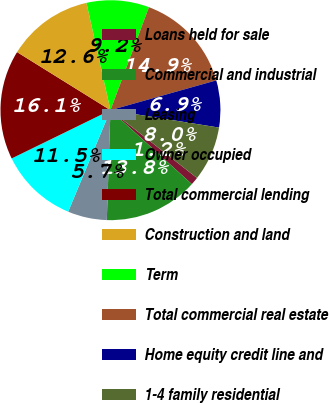Convert chart to OTSL. <chart><loc_0><loc_0><loc_500><loc_500><pie_chart><fcel>Loans held for sale<fcel>Commercial and industrial<fcel>Leasing<fcel>Owner occupied<fcel>Total commercial lending<fcel>Construction and land<fcel>Term<fcel>Total commercial real estate<fcel>Home equity credit line and<fcel>1-4 family residential<nl><fcel>1.16%<fcel>13.79%<fcel>5.75%<fcel>11.49%<fcel>16.09%<fcel>12.64%<fcel>9.2%<fcel>14.94%<fcel>6.9%<fcel>8.05%<nl></chart> 